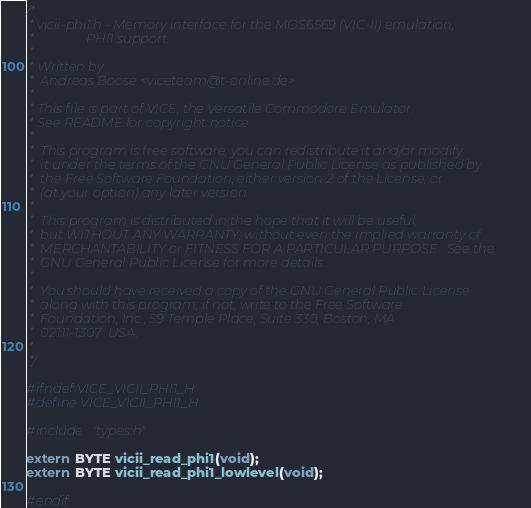<code> <loc_0><loc_0><loc_500><loc_500><_C_>/*
 * vicii-phi1.h - Memory interface for the MOS6569 (VIC-II) emulation,
 *                PHI1 support.
 *
 * Written by
 *  Andreas Boose <viceteam@t-online.de>
 *
 * This file is part of VICE, the Versatile Commodore Emulator.
 * See README for copyright notice.
 *
 *  This program is free software; you can redistribute it and/or modify
 *  it under the terms of the GNU General Public License as published by
 *  the Free Software Foundation; either version 2 of the License, or
 *  (at your option) any later version.
 *
 *  This program is distributed in the hope that it will be useful,
 *  but WITHOUT ANY WARRANTY; without even the implied warranty of
 *  MERCHANTABILITY or FITNESS FOR A PARTICULAR PURPOSE.  See the
 *  GNU General Public License for more details.
 *
 *  You should have received a copy of the GNU General Public License
 *  along with this program; if not, write to the Free Software
 *  Foundation, Inc., 59 Temple Place, Suite 330, Boston, MA
 *  02111-1307  USA.
 *
 */

#ifndef VICE_VICII_PHI1_H
#define VICE_VICII_PHI1_H

#include "types.h"

extern BYTE vicii_read_phi1(void);
extern BYTE vicii_read_phi1_lowlevel(void);

#endif

</code> 